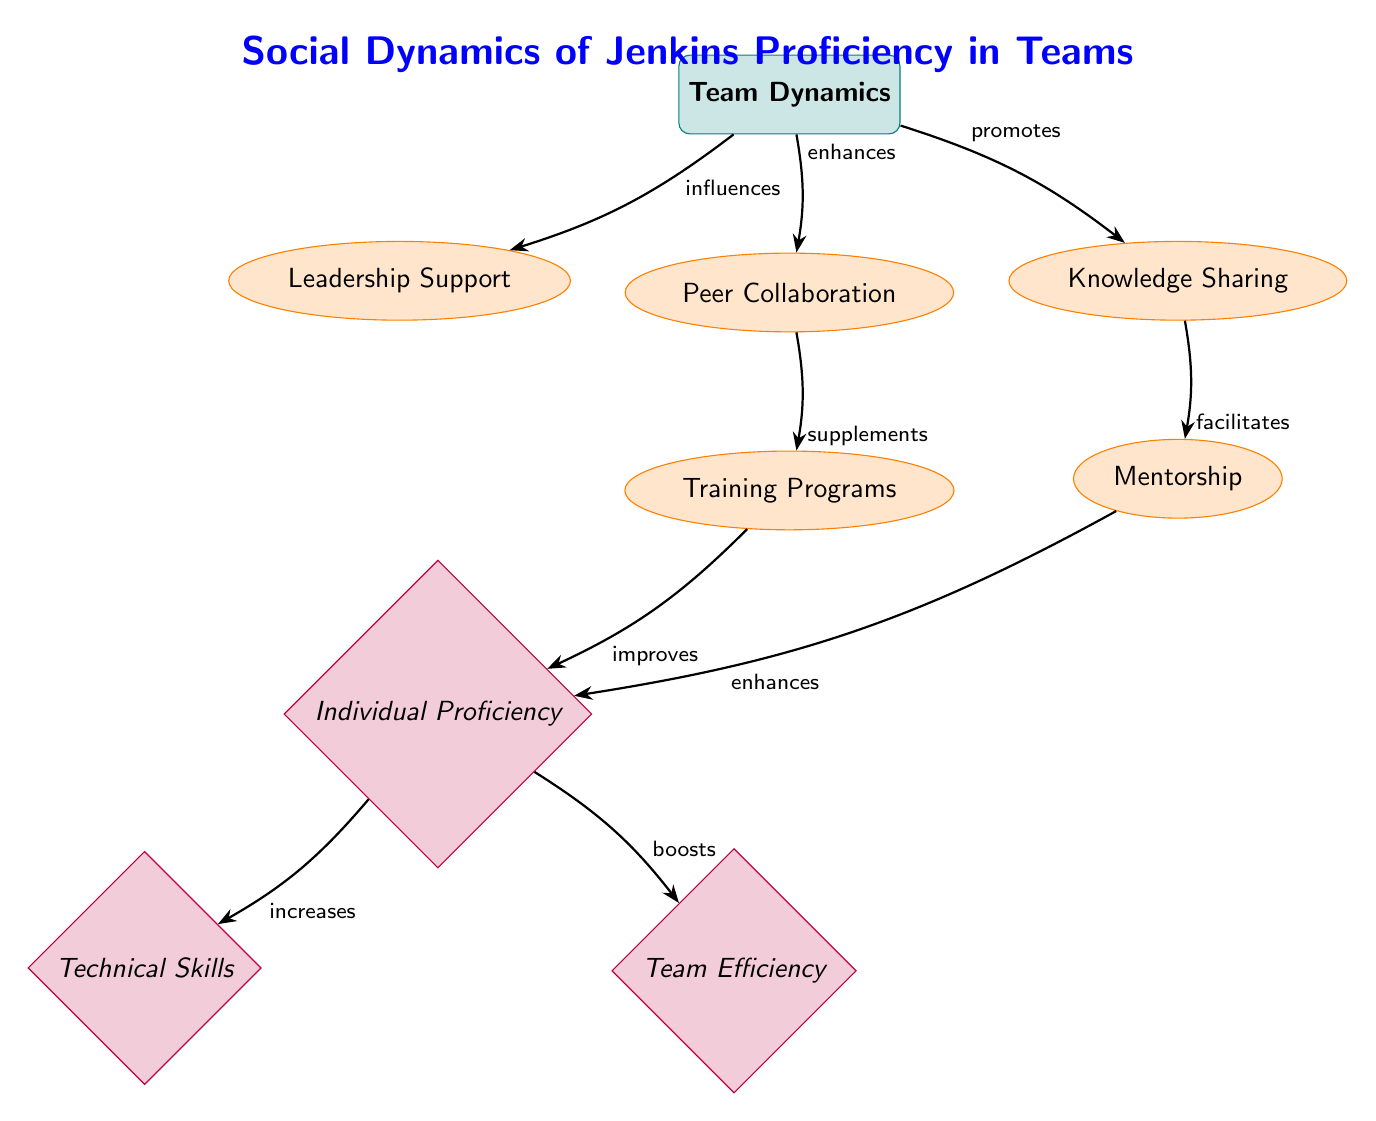What are the three factors influencing team dynamics? The diagram shows three factors connected to "Team Dynamics": "Leadership Support," "Peer Collaboration," and "Knowledge Sharing." These are explicitly listed below the category node.
Answer: Leadership Support, Peer Collaboration, Knowledge Sharing How many edges are in the diagram? By counting the arrows connecting the nodes, there are a total of 8 edges drawn in the diagram. Each connection is represented as an arrow from one node to another.
Answer: 8 What does "Peer Collaboration" supplement? According to the diagram, "Peer Collaboration" directly impacts or supplements the node labeled "Training Programs," as indicated by the edge connecting the two.
Answer: Training Programs Which factor enhances individual proficiency? The diagram shows two factors influencing "Individual Proficiency": "Training Programs" and "Mentorship." Both have paths leading to "Individual Proficiency," but the question specifies enhancement.
Answer: Mentorship What is the outcome of increased individual proficiency? The diagram illustrates two outcomes from "Individual Proficiency": "Technical Skills" and "Team Efficiency." Each outcome is directly connected to "Individual Proficiency," reflecting the impact of individual growth.
Answer: Technical Skills, Team Efficiency Which two nodes have a direct influence on team efficiency? The analysis of the diagram reveals that "Technical Skills" and "Individual Proficiency" both impact "Team Efficiency," as indicated by the path leading to the team efficiency outcome, thus these two nodes have a connection influencing it.
Answer: Individual Proficiency, Technical Skills What effect does "Knowledge Sharing" have? The diagram indicates that "Knowledge Sharing" promotes "Mentorship." This connection shows that knowledge should lead to enhanced mentorship within teams.
Answer: Promotes Mentorship How many outcomes are there in the diagram? By examining the bottom section of the diagram, there are two outcomes listed under "Individual Proficiency": "Technical Skills" and "Team Efficiency," confirming there are a total of 2 outcomes present.
Answer: 2 